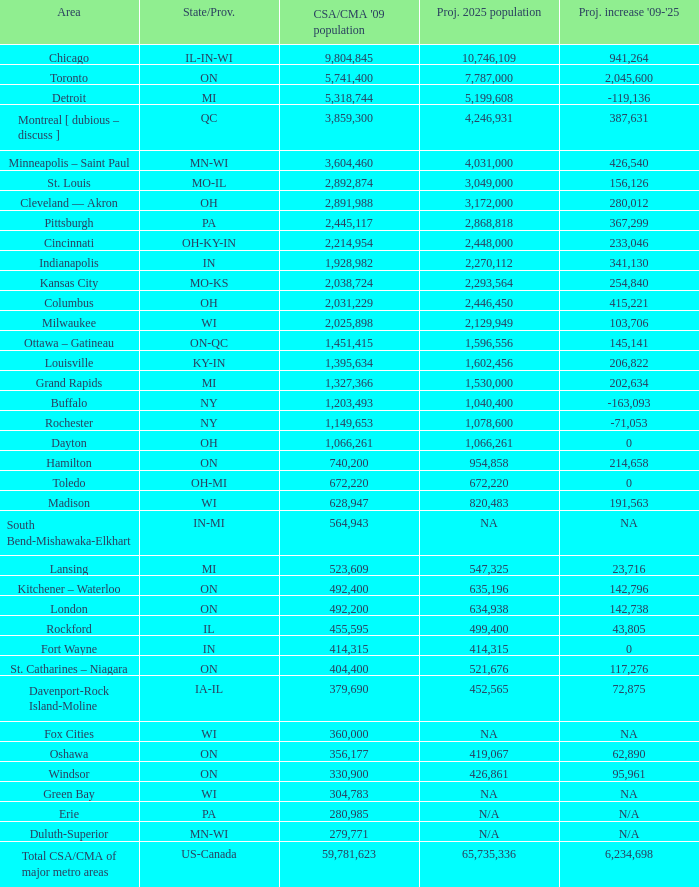What's the projected population of IN-MI? NA. Would you mind parsing the complete table? {'header': ['Area', 'State/Prov.', "CSA/CMA '09 population", 'Proj. 2025 population', "Proj. increase '09-'25"], 'rows': [['Chicago', 'IL-IN-WI', '9,804,845', '10,746,109', '941,264'], ['Toronto', 'ON', '5,741,400', '7,787,000', '2,045,600'], ['Detroit', 'MI', '5,318,744', '5,199,608', '-119,136'], ['Montreal [ dubious – discuss ]', 'QC', '3,859,300', '4,246,931', '387,631'], ['Minneapolis – Saint Paul', 'MN-WI', '3,604,460', '4,031,000', '426,540'], ['St. Louis', 'MO-IL', '2,892,874', '3,049,000', '156,126'], ['Cleveland — Akron', 'OH', '2,891,988', '3,172,000', '280,012'], ['Pittsburgh', 'PA', '2,445,117', '2,868,818', '367,299'], ['Cincinnati', 'OH-KY-IN', '2,214,954', '2,448,000', '233,046'], ['Indianapolis', 'IN', '1,928,982', '2,270,112', '341,130'], ['Kansas City', 'MO-KS', '2,038,724', '2,293,564', '254,840'], ['Columbus', 'OH', '2,031,229', '2,446,450', '415,221'], ['Milwaukee', 'WI', '2,025,898', '2,129,949', '103,706'], ['Ottawa – Gatineau', 'ON-QC', '1,451,415', '1,596,556', '145,141'], ['Louisville', 'KY-IN', '1,395,634', '1,602,456', '206,822'], ['Grand Rapids', 'MI', '1,327,366', '1,530,000', '202,634'], ['Buffalo', 'NY', '1,203,493', '1,040,400', '-163,093'], ['Rochester', 'NY', '1,149,653', '1,078,600', '-71,053'], ['Dayton', 'OH', '1,066,261', '1,066,261', '0'], ['Hamilton', 'ON', '740,200', '954,858', '214,658'], ['Toledo', 'OH-MI', '672,220', '672,220', '0'], ['Madison', 'WI', '628,947', '820,483', '191,563'], ['South Bend-Mishawaka-Elkhart', 'IN-MI', '564,943', 'NA', 'NA'], ['Lansing', 'MI', '523,609', '547,325', '23,716'], ['Kitchener – Waterloo', 'ON', '492,400', '635,196', '142,796'], ['London', 'ON', '492,200', '634,938', '142,738'], ['Rockford', 'IL', '455,595', '499,400', '43,805'], ['Fort Wayne', 'IN', '414,315', '414,315', '0'], ['St. Catharines – Niagara', 'ON', '404,400', '521,676', '117,276'], ['Davenport-Rock Island-Moline', 'IA-IL', '379,690', '452,565', '72,875'], ['Fox Cities', 'WI', '360,000', 'NA', 'NA'], ['Oshawa', 'ON', '356,177', '419,067', '62,890'], ['Windsor', 'ON', '330,900', '426,861', '95,961'], ['Green Bay', 'WI', '304,783', 'NA', 'NA'], ['Erie', 'PA', '280,985', 'N/A', 'N/A'], ['Duluth-Superior', 'MN-WI', '279,771', 'N/A', 'N/A'], ['Total CSA/CMA of major metro areas', 'US-Canada', '59,781,623', '65,735,336', '6,234,698']]} 